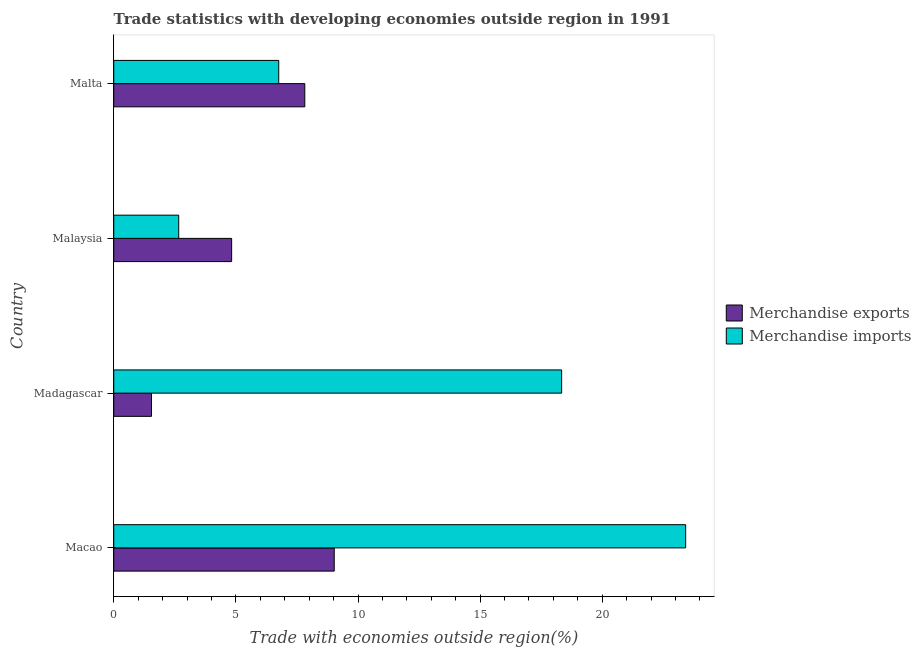How many different coloured bars are there?
Make the answer very short. 2. How many groups of bars are there?
Your answer should be very brief. 4. Are the number of bars per tick equal to the number of legend labels?
Provide a short and direct response. Yes. Are the number of bars on each tick of the Y-axis equal?
Offer a very short reply. Yes. How many bars are there on the 4th tick from the top?
Offer a very short reply. 2. How many bars are there on the 1st tick from the bottom?
Your answer should be very brief. 2. What is the label of the 2nd group of bars from the top?
Keep it short and to the point. Malaysia. What is the merchandise exports in Malta?
Offer a very short reply. 7.82. Across all countries, what is the maximum merchandise imports?
Provide a short and direct response. 23.42. Across all countries, what is the minimum merchandise exports?
Keep it short and to the point. 1.55. In which country was the merchandise imports maximum?
Ensure brevity in your answer.  Macao. In which country was the merchandise exports minimum?
Offer a very short reply. Madagascar. What is the total merchandise exports in the graph?
Provide a succinct answer. 23.22. What is the difference between the merchandise exports in Madagascar and that in Malta?
Ensure brevity in your answer.  -6.28. What is the difference between the merchandise exports in Madagascar and the merchandise imports in Macao?
Offer a very short reply. -21.87. What is the average merchandise imports per country?
Provide a short and direct response. 12.79. What is the difference between the merchandise imports and merchandise exports in Macao?
Your answer should be very brief. 14.39. What is the ratio of the merchandise exports in Malaysia to that in Malta?
Offer a terse response. 0.62. Is the difference between the merchandise exports in Macao and Malaysia greater than the difference between the merchandise imports in Macao and Malaysia?
Offer a terse response. No. What is the difference between the highest and the second highest merchandise imports?
Ensure brevity in your answer.  5.08. What is the difference between the highest and the lowest merchandise exports?
Your answer should be very brief. 7.48. Is the sum of the merchandise imports in Macao and Madagascar greater than the maximum merchandise exports across all countries?
Provide a succinct answer. Yes. What does the 1st bar from the top in Malaysia represents?
Ensure brevity in your answer.  Merchandise imports. What is the difference between two consecutive major ticks on the X-axis?
Your response must be concise. 5. Does the graph contain grids?
Give a very brief answer. No. How many legend labels are there?
Provide a short and direct response. 2. What is the title of the graph?
Your response must be concise. Trade statistics with developing economies outside region in 1991. Does "Lowest 20% of population" appear as one of the legend labels in the graph?
Provide a short and direct response. No. What is the label or title of the X-axis?
Offer a terse response. Trade with economies outside region(%). What is the label or title of the Y-axis?
Give a very brief answer. Country. What is the Trade with economies outside region(%) of Merchandise exports in Macao?
Make the answer very short. 9.03. What is the Trade with economies outside region(%) in Merchandise imports in Macao?
Make the answer very short. 23.42. What is the Trade with economies outside region(%) in Merchandise exports in Madagascar?
Offer a terse response. 1.55. What is the Trade with economies outside region(%) of Merchandise imports in Madagascar?
Ensure brevity in your answer.  18.34. What is the Trade with economies outside region(%) of Merchandise exports in Malaysia?
Make the answer very short. 4.83. What is the Trade with economies outside region(%) in Merchandise imports in Malaysia?
Provide a succinct answer. 2.66. What is the Trade with economies outside region(%) of Merchandise exports in Malta?
Make the answer very short. 7.82. What is the Trade with economies outside region(%) in Merchandise imports in Malta?
Make the answer very short. 6.76. Across all countries, what is the maximum Trade with economies outside region(%) of Merchandise exports?
Provide a succinct answer. 9.03. Across all countries, what is the maximum Trade with economies outside region(%) of Merchandise imports?
Your answer should be compact. 23.42. Across all countries, what is the minimum Trade with economies outside region(%) in Merchandise exports?
Offer a very short reply. 1.55. Across all countries, what is the minimum Trade with economies outside region(%) in Merchandise imports?
Your response must be concise. 2.66. What is the total Trade with economies outside region(%) of Merchandise exports in the graph?
Your response must be concise. 23.22. What is the total Trade with economies outside region(%) in Merchandise imports in the graph?
Ensure brevity in your answer.  51.17. What is the difference between the Trade with economies outside region(%) of Merchandise exports in Macao and that in Madagascar?
Provide a short and direct response. 7.48. What is the difference between the Trade with economies outside region(%) in Merchandise imports in Macao and that in Madagascar?
Offer a terse response. 5.08. What is the difference between the Trade with economies outside region(%) in Merchandise imports in Macao and that in Malaysia?
Your answer should be compact. 20.76. What is the difference between the Trade with economies outside region(%) in Merchandise exports in Macao and that in Malta?
Ensure brevity in your answer.  1.2. What is the difference between the Trade with economies outside region(%) in Merchandise imports in Macao and that in Malta?
Offer a very short reply. 16.66. What is the difference between the Trade with economies outside region(%) of Merchandise exports in Madagascar and that in Malaysia?
Your response must be concise. -3.28. What is the difference between the Trade with economies outside region(%) in Merchandise imports in Madagascar and that in Malaysia?
Offer a terse response. 15.68. What is the difference between the Trade with economies outside region(%) in Merchandise exports in Madagascar and that in Malta?
Your response must be concise. -6.28. What is the difference between the Trade with economies outside region(%) in Merchandise imports in Madagascar and that in Malta?
Ensure brevity in your answer.  11.58. What is the difference between the Trade with economies outside region(%) in Merchandise exports in Malaysia and that in Malta?
Provide a succinct answer. -3. What is the difference between the Trade with economies outside region(%) in Merchandise imports in Malaysia and that in Malta?
Ensure brevity in your answer.  -4.09. What is the difference between the Trade with economies outside region(%) in Merchandise exports in Macao and the Trade with economies outside region(%) in Merchandise imports in Madagascar?
Offer a terse response. -9.31. What is the difference between the Trade with economies outside region(%) in Merchandise exports in Macao and the Trade with economies outside region(%) in Merchandise imports in Malaysia?
Your answer should be very brief. 6.37. What is the difference between the Trade with economies outside region(%) in Merchandise exports in Macao and the Trade with economies outside region(%) in Merchandise imports in Malta?
Your response must be concise. 2.27. What is the difference between the Trade with economies outside region(%) in Merchandise exports in Madagascar and the Trade with economies outside region(%) in Merchandise imports in Malaysia?
Your answer should be compact. -1.11. What is the difference between the Trade with economies outside region(%) of Merchandise exports in Madagascar and the Trade with economies outside region(%) of Merchandise imports in Malta?
Your answer should be very brief. -5.21. What is the difference between the Trade with economies outside region(%) in Merchandise exports in Malaysia and the Trade with economies outside region(%) in Merchandise imports in Malta?
Offer a terse response. -1.93. What is the average Trade with economies outside region(%) of Merchandise exports per country?
Your response must be concise. 5.81. What is the average Trade with economies outside region(%) of Merchandise imports per country?
Your answer should be very brief. 12.79. What is the difference between the Trade with economies outside region(%) in Merchandise exports and Trade with economies outside region(%) in Merchandise imports in Macao?
Ensure brevity in your answer.  -14.39. What is the difference between the Trade with economies outside region(%) in Merchandise exports and Trade with economies outside region(%) in Merchandise imports in Madagascar?
Your answer should be compact. -16.79. What is the difference between the Trade with economies outside region(%) in Merchandise exports and Trade with economies outside region(%) in Merchandise imports in Malaysia?
Make the answer very short. 2.17. What is the difference between the Trade with economies outside region(%) of Merchandise exports and Trade with economies outside region(%) of Merchandise imports in Malta?
Your answer should be compact. 1.07. What is the ratio of the Trade with economies outside region(%) of Merchandise exports in Macao to that in Madagascar?
Your answer should be compact. 5.84. What is the ratio of the Trade with economies outside region(%) in Merchandise imports in Macao to that in Madagascar?
Provide a short and direct response. 1.28. What is the ratio of the Trade with economies outside region(%) in Merchandise exports in Macao to that in Malaysia?
Offer a very short reply. 1.87. What is the ratio of the Trade with economies outside region(%) of Merchandise imports in Macao to that in Malaysia?
Offer a very short reply. 8.8. What is the ratio of the Trade with economies outside region(%) of Merchandise exports in Macao to that in Malta?
Your answer should be very brief. 1.15. What is the ratio of the Trade with economies outside region(%) in Merchandise imports in Macao to that in Malta?
Provide a short and direct response. 3.47. What is the ratio of the Trade with economies outside region(%) of Merchandise exports in Madagascar to that in Malaysia?
Ensure brevity in your answer.  0.32. What is the ratio of the Trade with economies outside region(%) of Merchandise imports in Madagascar to that in Malaysia?
Give a very brief answer. 6.89. What is the ratio of the Trade with economies outside region(%) in Merchandise exports in Madagascar to that in Malta?
Give a very brief answer. 0.2. What is the ratio of the Trade with economies outside region(%) of Merchandise imports in Madagascar to that in Malta?
Ensure brevity in your answer.  2.71. What is the ratio of the Trade with economies outside region(%) of Merchandise exports in Malaysia to that in Malta?
Ensure brevity in your answer.  0.62. What is the ratio of the Trade with economies outside region(%) of Merchandise imports in Malaysia to that in Malta?
Your answer should be compact. 0.39. What is the difference between the highest and the second highest Trade with economies outside region(%) in Merchandise exports?
Ensure brevity in your answer.  1.2. What is the difference between the highest and the second highest Trade with economies outside region(%) of Merchandise imports?
Your response must be concise. 5.08. What is the difference between the highest and the lowest Trade with economies outside region(%) of Merchandise exports?
Your answer should be compact. 7.48. What is the difference between the highest and the lowest Trade with economies outside region(%) of Merchandise imports?
Offer a very short reply. 20.76. 